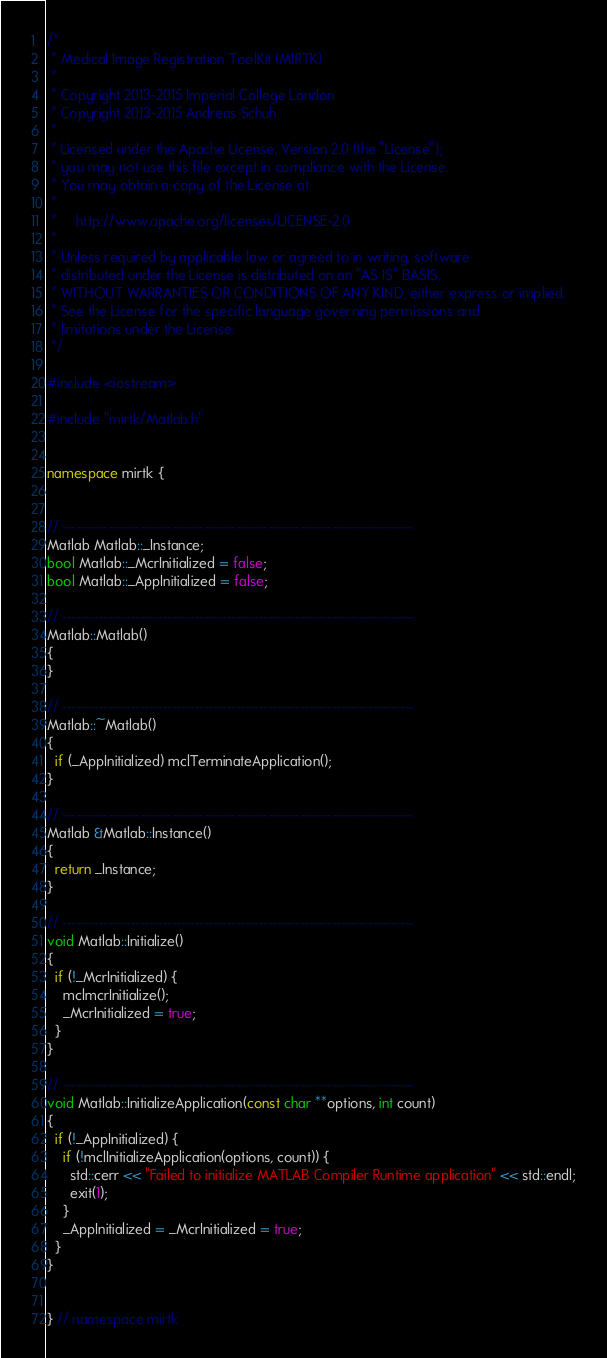<code> <loc_0><loc_0><loc_500><loc_500><_C++_>/*
 * Medical Image Registration ToolKit (MIRTK)
 *
 * Copyright 2013-2015 Imperial College London
 * Copyright 2013-2015 Andreas Schuh
 *
 * Licensed under the Apache License, Version 2.0 (the "License");
 * you may not use this file except in compliance with the License.
 * You may obtain a copy of the License at
 *
 *     http://www.apache.org/licenses/LICENSE-2.0
 *
 * Unless required by applicable law or agreed to in writing, software
 * distributed under the License is distributed on an "AS IS" BASIS,
 * WITHOUT WARRANTIES OR CONDITIONS OF ANY KIND, either express or implied.
 * See the License for the specific language governing permissions and
 * limitations under the License.
 */

#include <iostream>

#include "mirtk/Matlab.h"


namespace mirtk {


// -----------------------------------------------------------------------------
Matlab Matlab::_Instance;
bool Matlab::_McrInitialized = false;
bool Matlab::_AppInitialized = false;

// -----------------------------------------------------------------------------
Matlab::Matlab()
{
}

// -----------------------------------------------------------------------------
Matlab::~Matlab()
{
  if (_AppInitialized) mclTerminateApplication();
}

// -----------------------------------------------------------------------------
Matlab &Matlab::Instance()
{
  return _Instance;
}

// -----------------------------------------------------------------------------
void Matlab::Initialize()
{
  if (!_McrInitialized) {
    mclmcrInitialize();
    _McrInitialized = true;
  }
}

// -----------------------------------------------------------------------------
void Matlab::InitializeApplication(const char **options, int count)
{
  if (!_AppInitialized) {
    if (!mclInitializeApplication(options, count)) {
      std::cerr << "Failed to initialize MATLAB Compiler Runtime application" << std::endl;
      exit(1);
    }
    _AppInitialized = _McrInitialized = true;
  }
}


} // namespace mirtk
</code> 